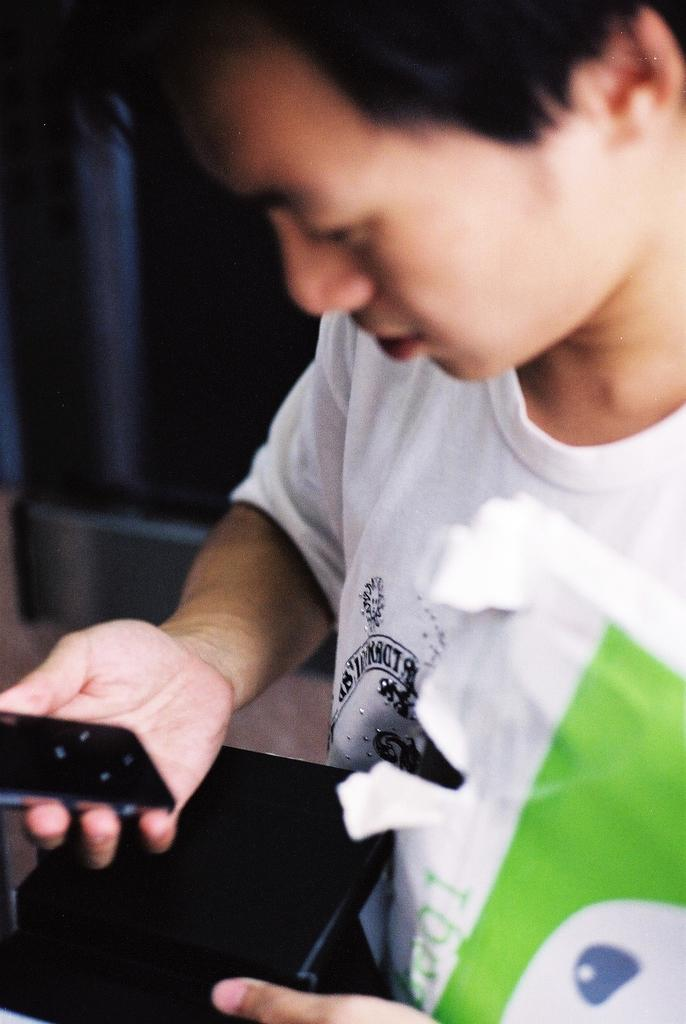What is the main subject of the image? There is a man in the image. What is the man wearing? The man is wearing a white shirt. What objects is the man holding in his left hand? The man is holding a mobile phone and a file in his left hand. What type of beetle can be seen crawling on the man's shirt in the image? There is no beetle present on the man's shirt in the image. 